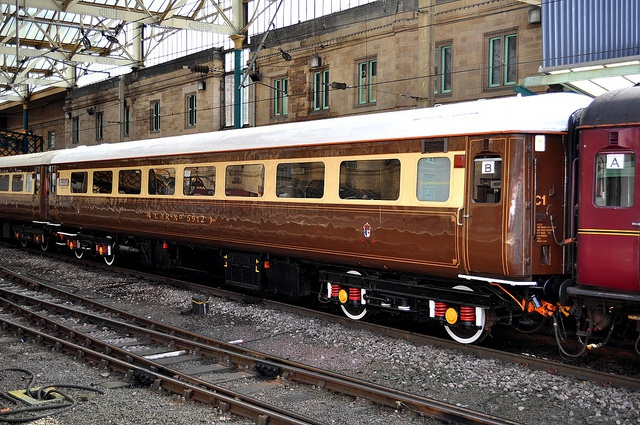Describe the objects in this image and their specific colors. I can see a train in gray, black, maroon, and white tones in this image. 